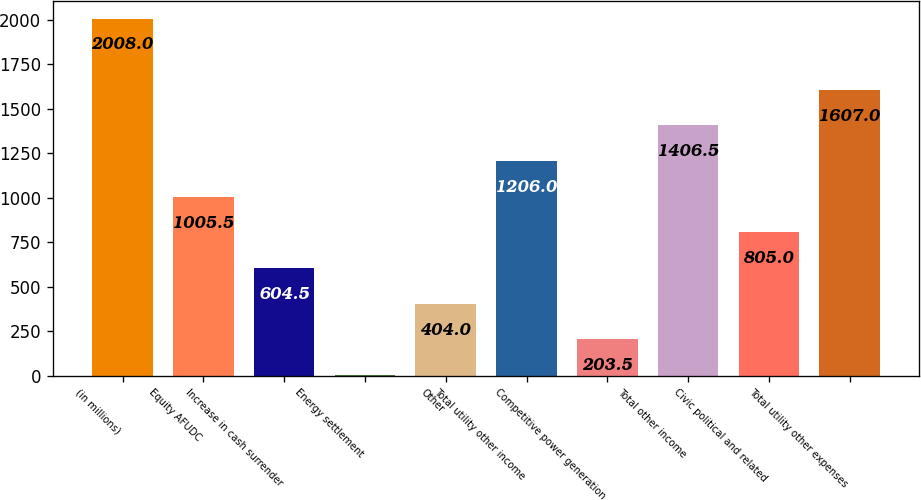Convert chart. <chart><loc_0><loc_0><loc_500><loc_500><bar_chart><fcel>(in millions)<fcel>Equity AFUDC<fcel>Increase in cash surrender<fcel>Energy settlement<fcel>Other<fcel>Total utility other income<fcel>Competitive power generation<fcel>Total other income<fcel>Civic political and related<fcel>Total utility other expenses<nl><fcel>2008<fcel>1005.5<fcel>604.5<fcel>3<fcel>404<fcel>1206<fcel>203.5<fcel>1406.5<fcel>805<fcel>1607<nl></chart> 